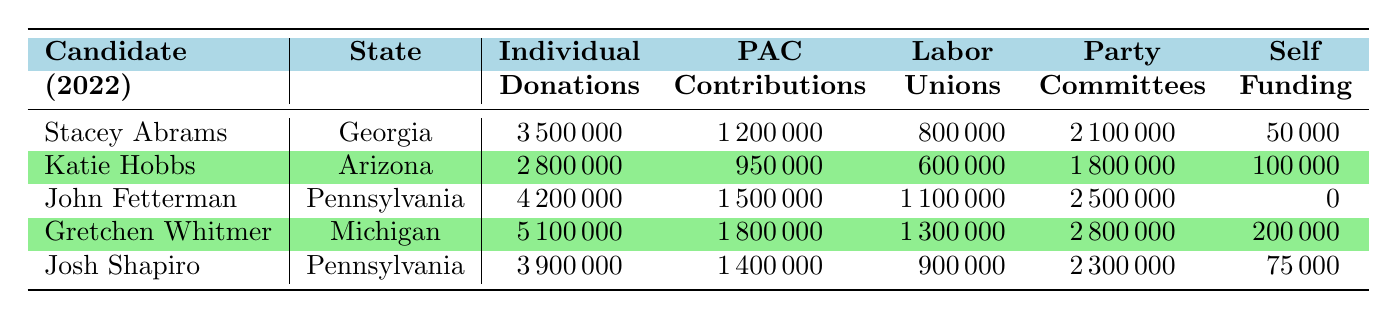What is the total amount of individual donations received by Stacey Abrams? Stacey Abrams received 3,500,000 in individual donations, which is clearly stated in the table under the "Individual Donations" column for her.
Answer: 3,500,000 Which candidate received the largest amount from PAC contributions? Looking at the "PAC Contributions" column, Gretchen Whitmer received 1,800,000, which is the highest value compared to the other candidates.
Answer: Gretchen Whitmer What is the sum of self-funding for John Fetterman and Josh Shapiro? John Fetterman self-funded 0, while Josh Shapiro self-funded 75,000. Adding these amounts gives 0 + 75,000 = 75,000.
Answer: 75,000 Did any candidate receive no funding from Labor Unions? Yes, John Fetterman received 0 from Labor Unions, which is indicated in the table under the "Labor Unions" column.
Answer: Yes Which state had the candidate with the highest total funding, and what was that amount? Gretchen Whitmer from Michigan had the highest total funding, calculated by adding all her funding sources: 5,100,000 + 1,800,000 + 1,300,000 + 2,800,000 + 200,000 = 11,200,000. The state is Michigan.
Answer: Michigan, 11,200,000 What is the average amount of funding received from Party Committees across all candidates? To find the average, first sum all the values in the "Party Committees" column, which are: 2,100,000 + 1,800,000 + 2,500,000 + 2,800,000 + 2,300,000 = 12,500,000. Then divide by the number of candidates (5): 12,500,000 / 5 = 2,500,000.
Answer: 2,500,000 Which funding source contributed the least to Josh Shapiro's campaign? In Josh Shapiro's row, the least amount of funding came from Self-Funding, which is 75,000.
Answer: Self-Funding What was the total funding for candidates from Pennsylvania, and how does it compare to Michigan's total funding? There were two candidates from Pennsylvania: John Fetterman with a total of 11,200,000 and Josh Shapiro with a total of 11,500,000 (adding all their funding sources respectively). This makes Pennsylvania's total 11,200,000 + 11,500,000 = 22,700,000. Michigan's candidate, Gretchen Whitmer, had total funding of 11,200,000. Thus, Pennsylvania had more total funding compared to Michigan.
Answer: Pennsylvania's total is 22,700,000; higher than Michigan's 11,200,000 Which candidate had the highest total from Individual Donations, and how much was it? From the "Individual Donations" column, Gretchen Whitmer had the highest figure at 5,100,000, as compared to the others.
Answer: Gretchen Whitmer, 5,100,000 Is the total funding of Katie Hobbs higher than Stacey Abrams? Katie Hobbs's total funding is 2,800,000 + 950,000 + 600,000 + 1,800,000 + 100,000 = 5,250,000. Stacey Abrams's total funding is 3,500,000 + 1,200,000 + 800,000 + 2,100,000 + 50,000 = 7,650,000. Since 5,250,000 is less than 7,650,000, Katie Hobbs does not have higher funding.
Answer: No 